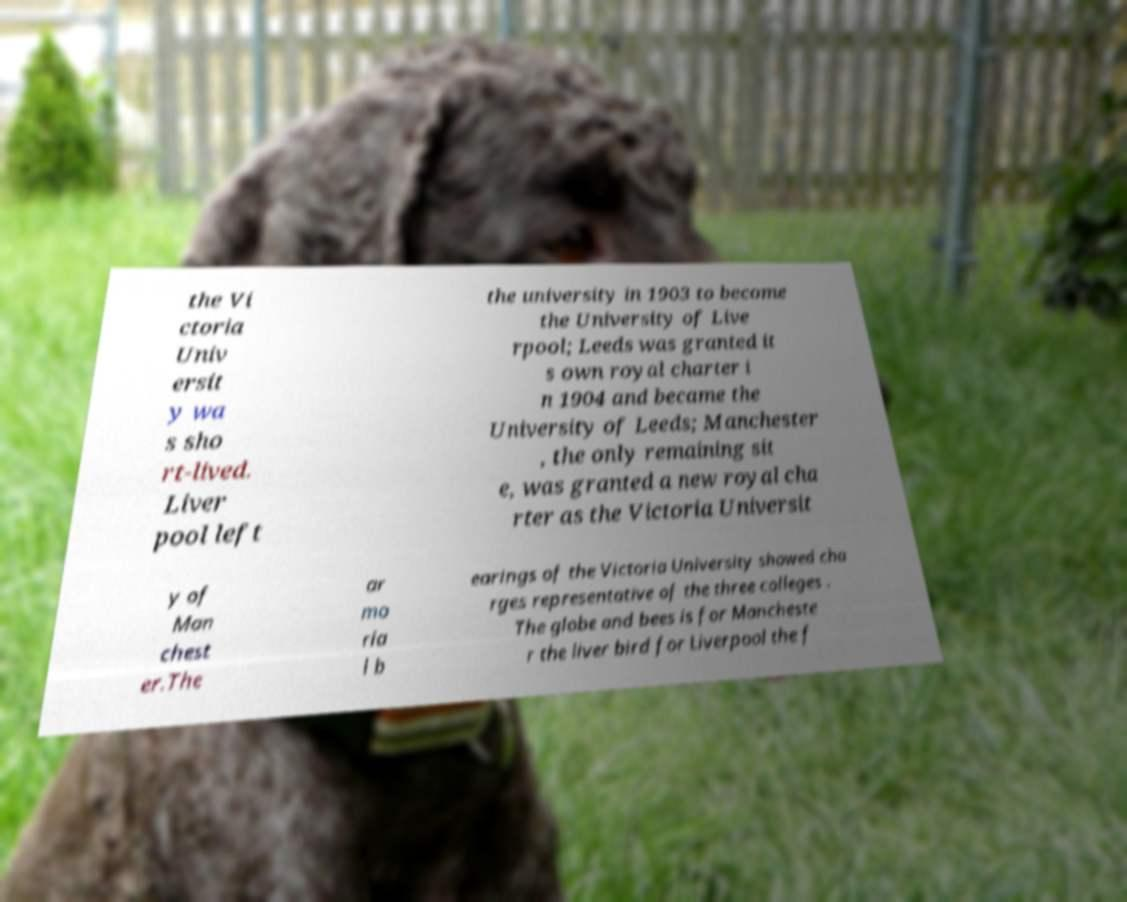There's text embedded in this image that I need extracted. Can you transcribe it verbatim? the Vi ctoria Univ ersit y wa s sho rt-lived. Liver pool left the university in 1903 to become the University of Live rpool; Leeds was granted it s own royal charter i n 1904 and became the University of Leeds; Manchester , the only remaining sit e, was granted a new royal cha rter as the Victoria Universit y of Man chest er.The ar mo ria l b earings of the Victoria University showed cha rges representative of the three colleges . The globe and bees is for Mancheste r the liver bird for Liverpool the f 